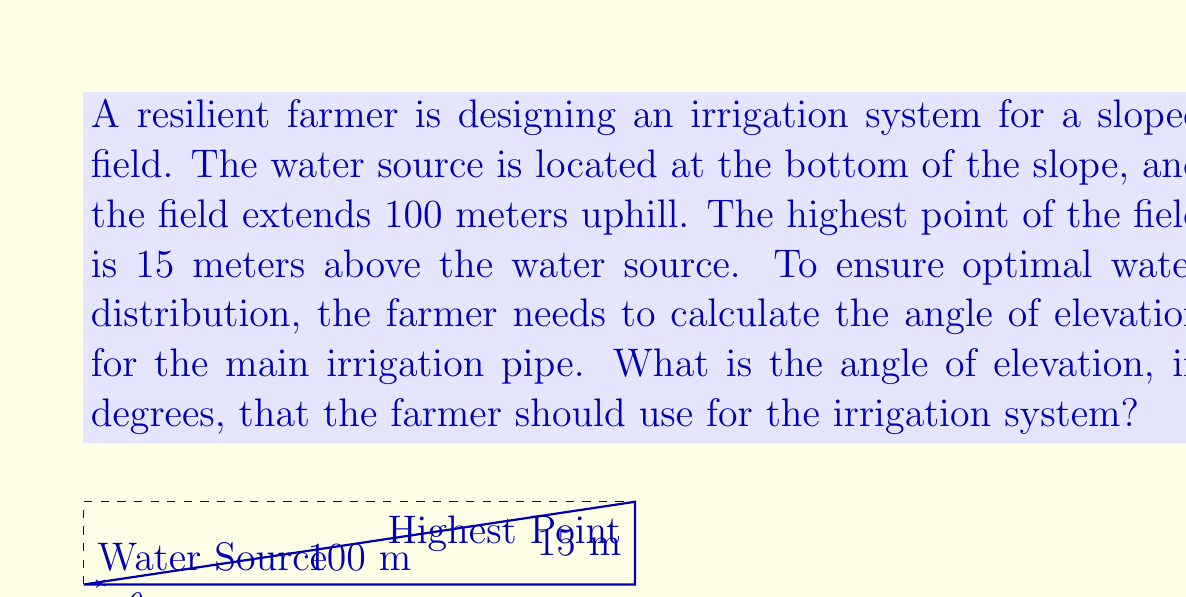Teach me how to tackle this problem. To solve this problem, we need to use basic trigonometry. We can treat the slope as a right triangle, where:

- The base (adjacent side) is the horizontal distance of 100 meters
- The height (opposite side) is the vertical distance of 15 meters
- The angle of elevation is the angle we're trying to find

We can use the tangent function to find this angle. The tangent of an angle in a right triangle is defined as the ratio of the opposite side to the adjacent side.

$$\tan(\theta) = \frac{\text{opposite}}{\text{adjacent}} = \frac{\text{height}}{\text{base}}$$

Plugging in our values:

$$\tan(\theta) = \frac{15}{100} = 0.15$$

To find the angle $\theta$, we need to use the inverse tangent (arctan or $\tan^{-1}$) function:

$$\theta = \tan^{-1}(0.15)$$

Using a calculator or computer:

$$\theta \approx 8.53°$$

Therefore, the angle of elevation for the irrigation system should be approximately 8.53 degrees.
Answer: $8.53°$ (rounded to two decimal places) 